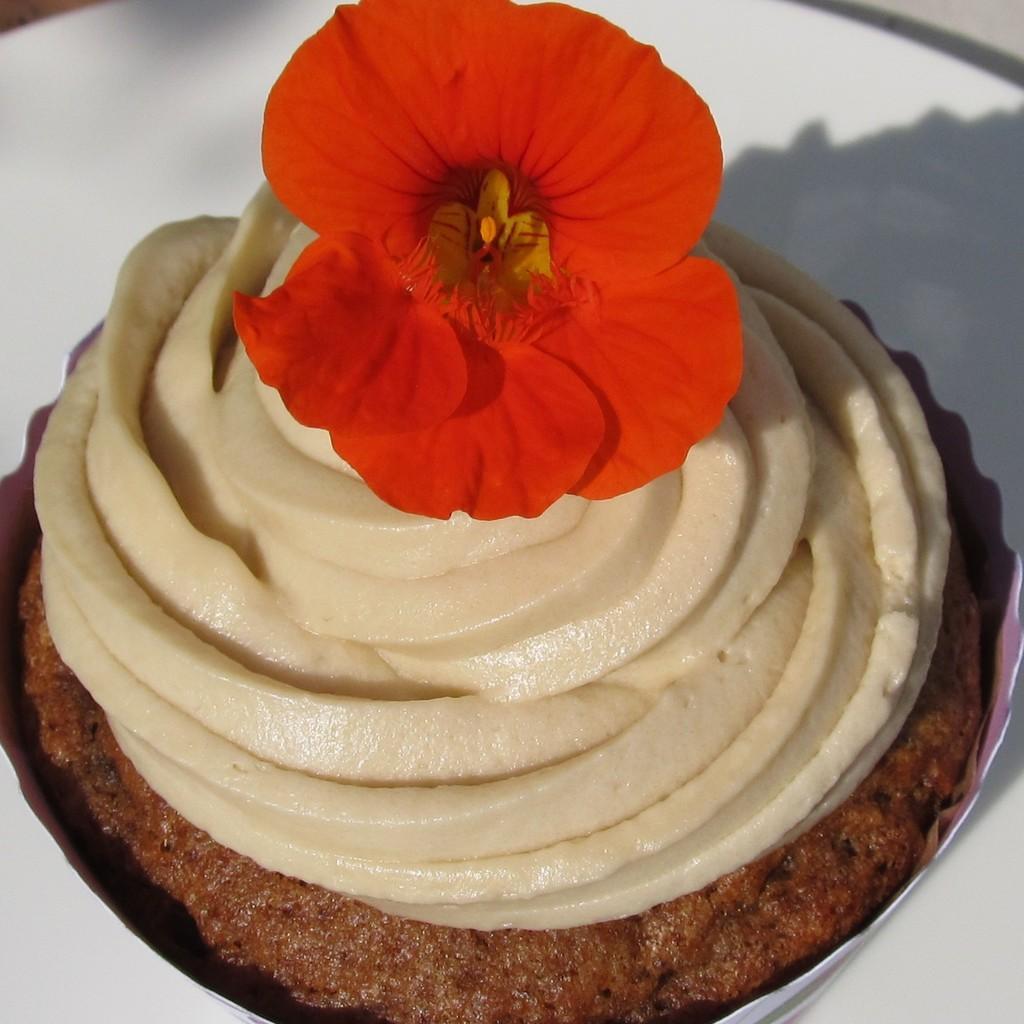In one or two sentences, can you explain what this image depicts? In this image there is a plate, on that plate there is a cake, on that there is a flower. 